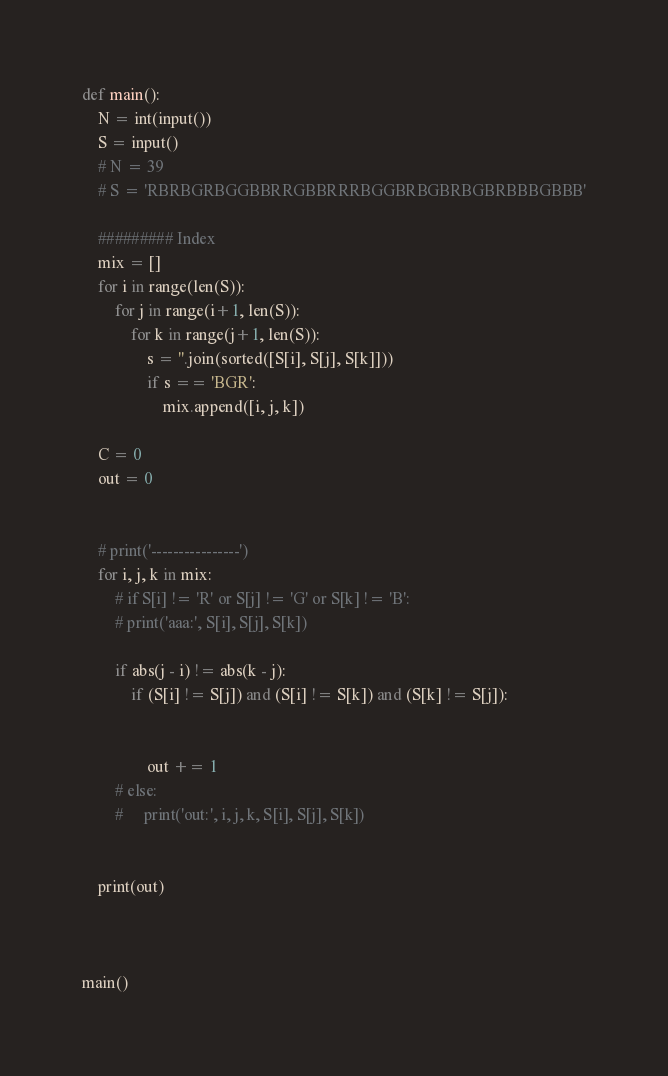Convert code to text. <code><loc_0><loc_0><loc_500><loc_500><_Python_>def main():
    N = int(input())
    S = input()
    # N = 39
    # S = 'RBRBGRBGGBBRRGBBRRRBGGBRBGBRBGBRBBBGBBB'
    
    ######### Index
    mix = []
    for i in range(len(S)):
        for j in range(i+1, len(S)):
            for k in range(j+1, len(S)):
                s = ''.join(sorted([S[i], S[j], S[k]]))
                if s == 'BGR':
                    mix.append([i, j, k])
    
    C = 0
    out = 0

    
    # print('----------------')
    for i, j, k in mix:
        # if S[i] != 'R' or S[j] != 'G' or S[k] != 'B':
        # print('aaa:', S[i], S[j], S[k])
        
        if abs(j - i) != abs(k - j):
            if (S[i] != S[j]) and (S[i] != S[k]) and (S[k] != S[j]):
            
                
                out += 1
        # else:
        #     print('out:', i, j, k, S[i], S[j], S[k])


    print(out)


    
main()</code> 